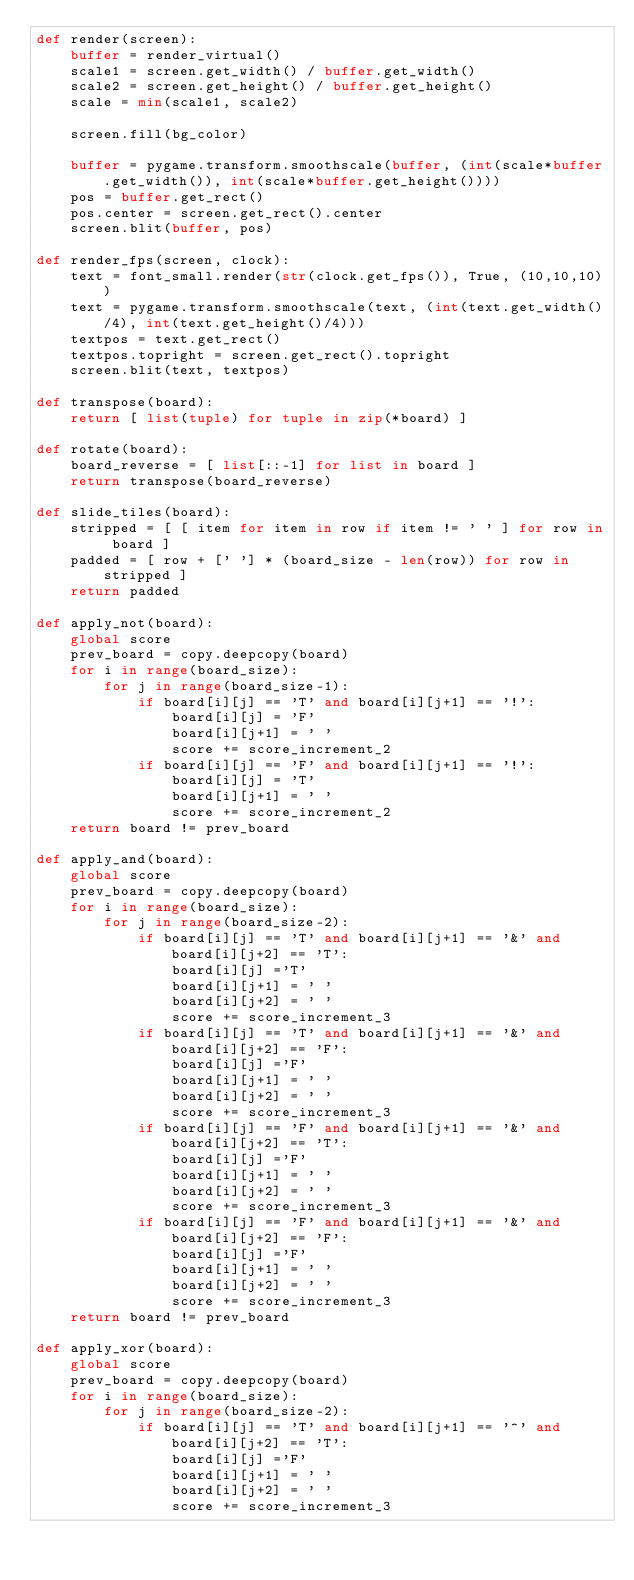<code> <loc_0><loc_0><loc_500><loc_500><_Python_>def render(screen):
    buffer = render_virtual()
    scale1 = screen.get_width() / buffer.get_width()
    scale2 = screen.get_height() / buffer.get_height()
    scale = min(scale1, scale2)
    
    screen.fill(bg_color)
    
    buffer = pygame.transform.smoothscale(buffer, (int(scale*buffer.get_width()), int(scale*buffer.get_height())))
    pos = buffer.get_rect()
    pos.center = screen.get_rect().center
    screen.blit(buffer, pos)
    
def render_fps(screen, clock):
    text = font_small.render(str(clock.get_fps()), True, (10,10,10))
    text = pygame.transform.smoothscale(text, (int(text.get_width()/4), int(text.get_height()/4)))
    textpos = text.get_rect()
    textpos.topright = screen.get_rect().topright
    screen.blit(text, textpos)

def transpose(board):
    return [ list(tuple) for tuple in zip(*board) ]
    
def rotate(board):
    board_reverse = [ list[::-1] for list in board ]
    return transpose(board_reverse)
    
def slide_tiles(board):
    stripped = [ [ item for item in row if item != ' ' ] for row in board ]
    padded = [ row + [' '] * (board_size - len(row)) for row in stripped ]
    return padded

def apply_not(board):
    global score
    prev_board = copy.deepcopy(board)
    for i in range(board_size):
        for j in range(board_size-1):
            if board[i][j] == 'T' and board[i][j+1] == '!':
                board[i][j] = 'F'
                board[i][j+1] = ' '
                score += score_increment_2
            if board[i][j] == 'F' and board[i][j+1] == '!':
                board[i][j] = 'T'
                board[i][j+1] = ' '
                score += score_increment_2
    return board != prev_board
    
def apply_and(board):
    global score
    prev_board = copy.deepcopy(board)
    for i in range(board_size):
        for j in range(board_size-2):
            if board[i][j] == 'T' and board[i][j+1] == '&' and board[i][j+2] == 'T':
                board[i][j] ='T'
                board[i][j+1] = ' '
                board[i][j+2] = ' '
                score += score_increment_3
            if board[i][j] == 'T' and board[i][j+1] == '&' and board[i][j+2] == 'F':
                board[i][j] ='F'
                board[i][j+1] = ' '
                board[i][j+2] = ' '
                score += score_increment_3
            if board[i][j] == 'F' and board[i][j+1] == '&' and board[i][j+2] == 'T':
                board[i][j] ='F'
                board[i][j+1] = ' '
                board[i][j+2] = ' '
                score += score_increment_3
            if board[i][j] == 'F' and board[i][j+1] == '&' and board[i][j+2] == 'F':
                board[i][j] ='F'
                board[i][j+1] = ' '
                board[i][j+2] = ' '
                score += score_increment_3
    return board != prev_board

def apply_xor(board):
    global score
    prev_board = copy.deepcopy(board)
    for i in range(board_size):
        for j in range(board_size-2):
            if board[i][j] == 'T' and board[i][j+1] == '^' and board[i][j+2] == 'T':
                board[i][j] ='F'
                board[i][j+1] = ' '
                board[i][j+2] = ' '
                score += score_increment_3</code> 